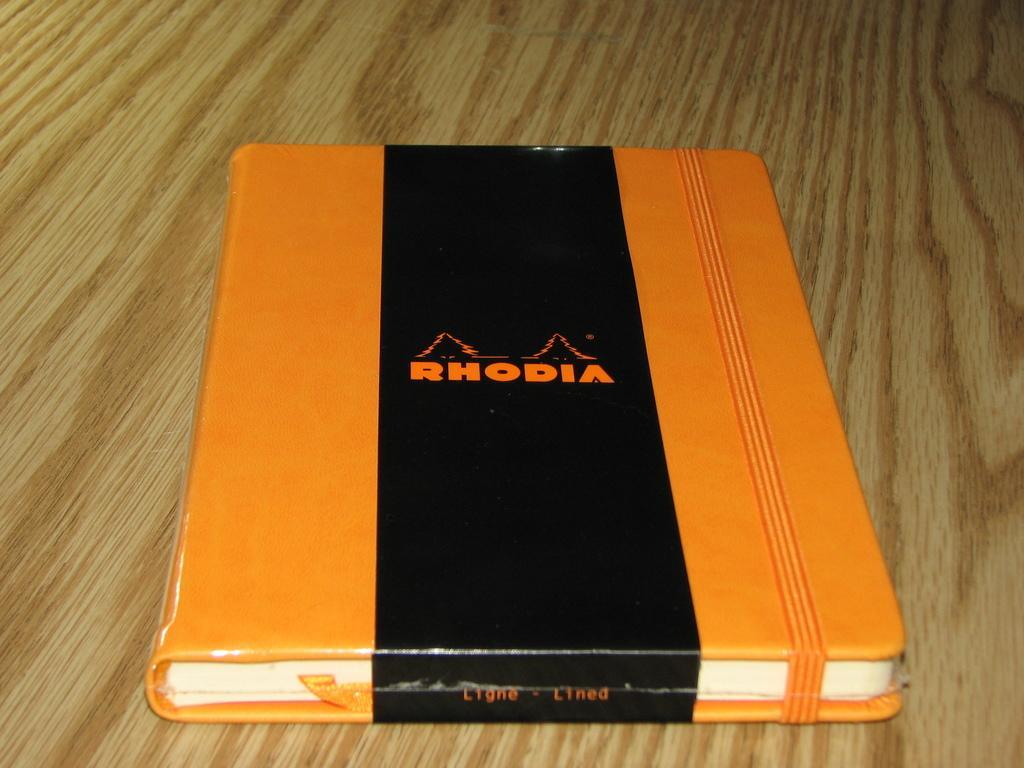<image>
Provide a brief description of the given image. An orange book with a black strap titled Rhodia is on the wooden floor. 